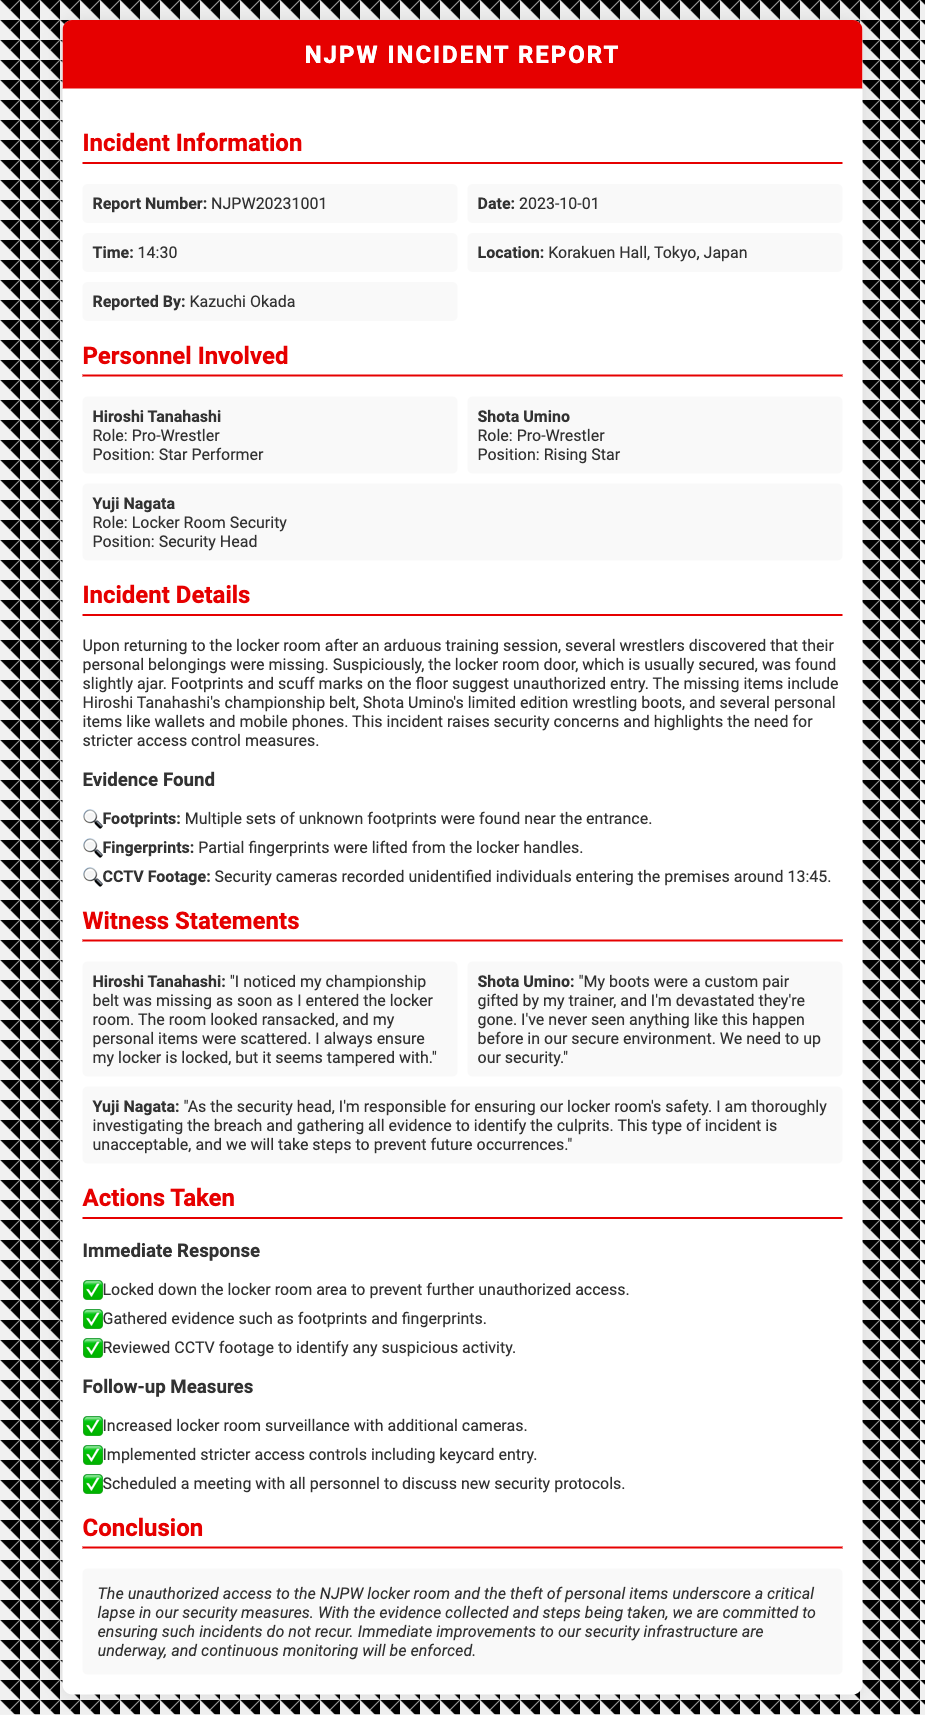What is the report number? The report number is provided in the incident information section of the document.
Answer: NJPW20231001 Who reported the incident? The reporter's name is listed under the reported by section in the incident information.
Answer: Kazuchi Okada What time did the incident occur? The time of the incident is mentioned in the incident information.
Answer: 14:30 What item belonging to Hiroshi Tanahashi was missing? The missing item is specified in the incident details about the personal belongings.
Answer: championship belt How many personnel are listed as involved? The total number of personnel can be counted from the personnel involved section.
Answer: 3 What immediate action was taken regarding the locker room? An immediate action in response to the incident is detailed in the actions taken section.
Answer: Locked down the locker room area What type of surveillance measure was implemented as a follow-up? A specific follow-up measure is outlined in the follow-up measures section.
Answer: Additional cameras What was the main conclusion regarding the incident? The conclusion provides a summary of the findings and future actions based on the incident.
Answer: critical lapse in our security measures What location did the incident take place in? The location is mentioned in the incident information part of the document.
Answer: Korakuen Hall, Tokyo, Japan 